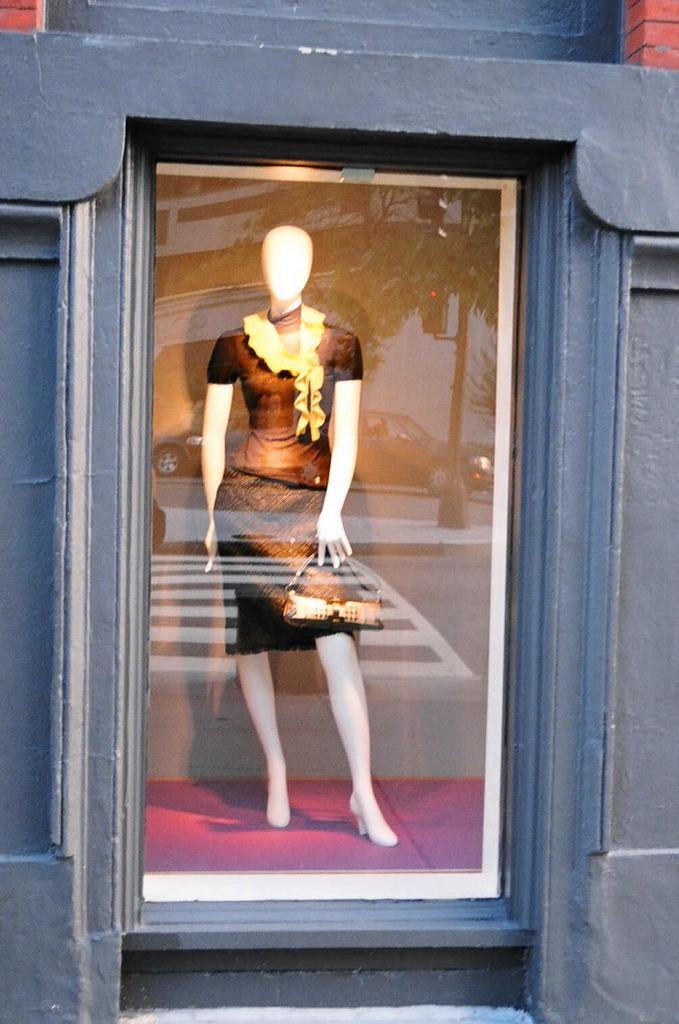Can you describe this image briefly? In this picture we can describe about statue wearing a black color dress and skirt is standing in the mirror box. 